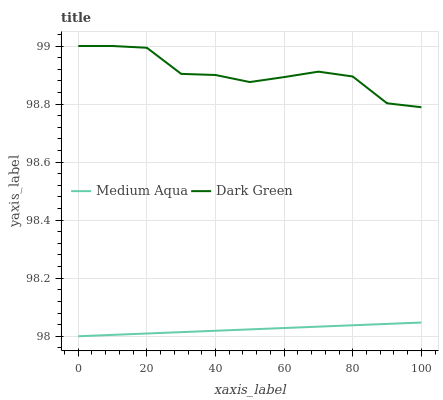Does Medium Aqua have the minimum area under the curve?
Answer yes or no. Yes. Does Dark Green have the maximum area under the curve?
Answer yes or no. Yes. Does Dark Green have the minimum area under the curve?
Answer yes or no. No. Is Medium Aqua the smoothest?
Answer yes or no. Yes. Is Dark Green the roughest?
Answer yes or no. Yes. Is Dark Green the smoothest?
Answer yes or no. No. Does Dark Green have the lowest value?
Answer yes or no. No. Does Dark Green have the highest value?
Answer yes or no. Yes. Is Medium Aqua less than Dark Green?
Answer yes or no. Yes. Is Dark Green greater than Medium Aqua?
Answer yes or no. Yes. Does Medium Aqua intersect Dark Green?
Answer yes or no. No. 